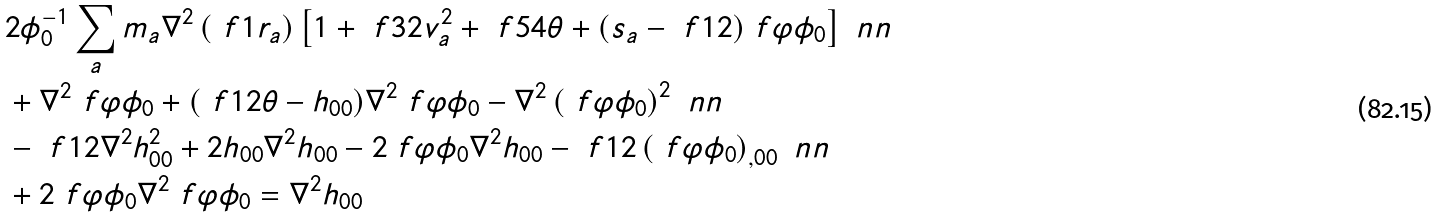<formula> <loc_0><loc_0><loc_500><loc_500>& 2 \phi _ { 0 } ^ { - 1 } \sum _ { a } m _ { a } \nabla ^ { 2 } \left ( \ f { 1 } { r _ { a } } \right ) \left [ 1 + \ f { 3 } { 2 } v _ { a } ^ { 2 } + \ f { 5 } { 4 } \theta + ( s _ { a } - \ f { 1 } { 2 } ) \ f { \varphi } { \phi _ { 0 } } \right ] \ n n \\ & + \nabla ^ { 2 } \ f { \varphi } { \phi _ { 0 } } + ( \ f { 1 } { 2 } \theta - h _ { 0 0 } ) \nabla ^ { 2 } \ f { \varphi } { \phi _ { 0 } } - \nabla ^ { 2 } \left ( \ f { \varphi } { \phi _ { 0 } } \right ) ^ { 2 } \ n n \\ & - \ f { 1 } { 2 } \nabla ^ { 2 } h _ { 0 0 } ^ { 2 } + 2 h _ { 0 0 } \nabla ^ { 2 } h _ { 0 0 } - 2 \ f { \varphi } { \phi _ { 0 } } \nabla ^ { 2 } h _ { 0 0 } - \ f { 1 } { 2 } \left ( \ f { \varphi } { \phi _ { 0 } } \right ) _ { , 0 0 } \ n n \\ & + 2 \ f { \varphi } { \phi _ { 0 } } \nabla ^ { 2 } \ f { \varphi } { \phi _ { 0 } } = \nabla ^ { 2 } h _ { 0 0 }</formula> 